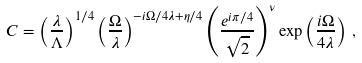<formula> <loc_0><loc_0><loc_500><loc_500>C = \left ( \frac { \lambda } { \Lambda } \right ) ^ { 1 / 4 } \left ( \frac { \Omega } { \lambda } \right ) ^ { - i \Omega / 4 \lambda + \eta / 4 } \left ( \frac { e ^ { i \pi / 4 } } { \sqrt { 2 } } \right ) ^ { \nu } \exp \left ( \frac { i \Omega } { 4 \lambda } \right ) \, ,</formula> 